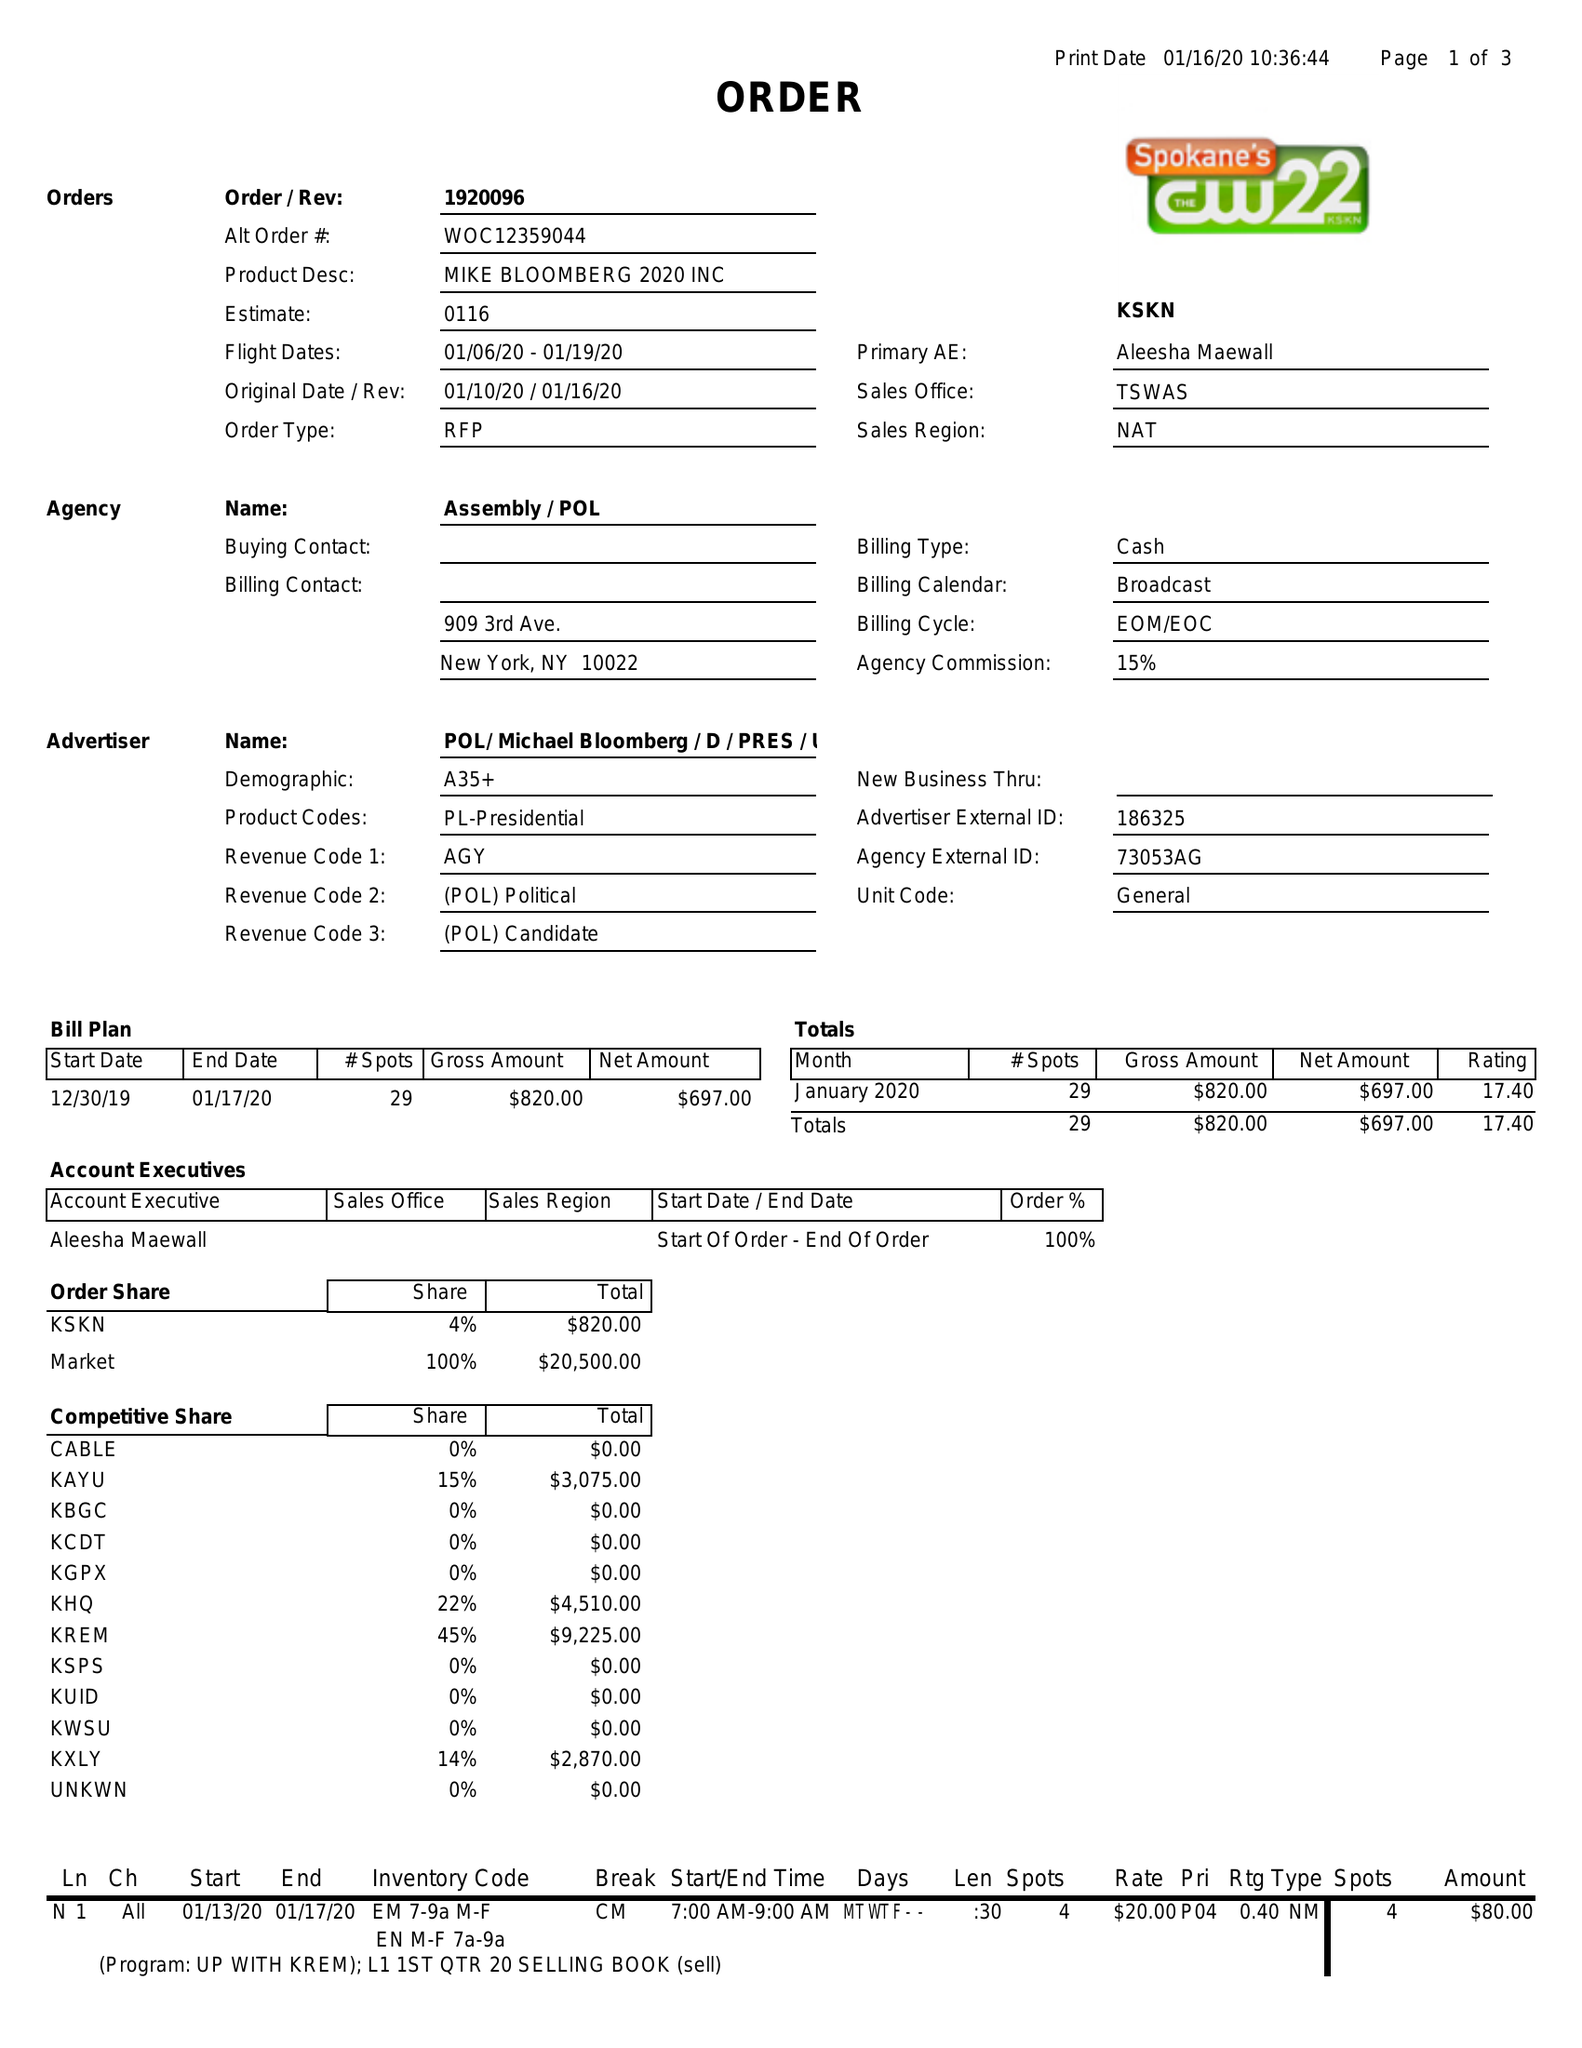What is the value for the advertiser?
Answer the question using a single word or phrase. POL/MICHAELBLOOMBERG/D/PRES/ 